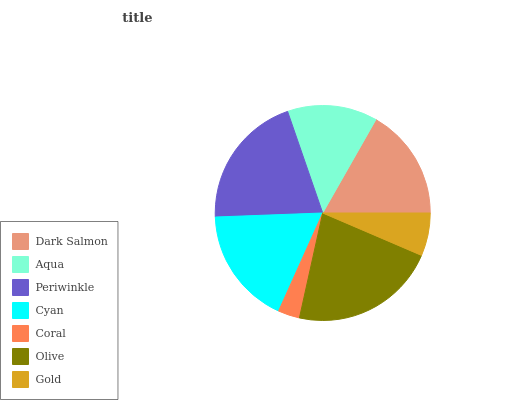Is Coral the minimum?
Answer yes or no. Yes. Is Olive the maximum?
Answer yes or no. Yes. Is Aqua the minimum?
Answer yes or no. No. Is Aqua the maximum?
Answer yes or no. No. Is Dark Salmon greater than Aqua?
Answer yes or no. Yes. Is Aqua less than Dark Salmon?
Answer yes or no. Yes. Is Aqua greater than Dark Salmon?
Answer yes or no. No. Is Dark Salmon less than Aqua?
Answer yes or no. No. Is Dark Salmon the high median?
Answer yes or no. Yes. Is Dark Salmon the low median?
Answer yes or no. Yes. Is Coral the high median?
Answer yes or no. No. Is Gold the low median?
Answer yes or no. No. 